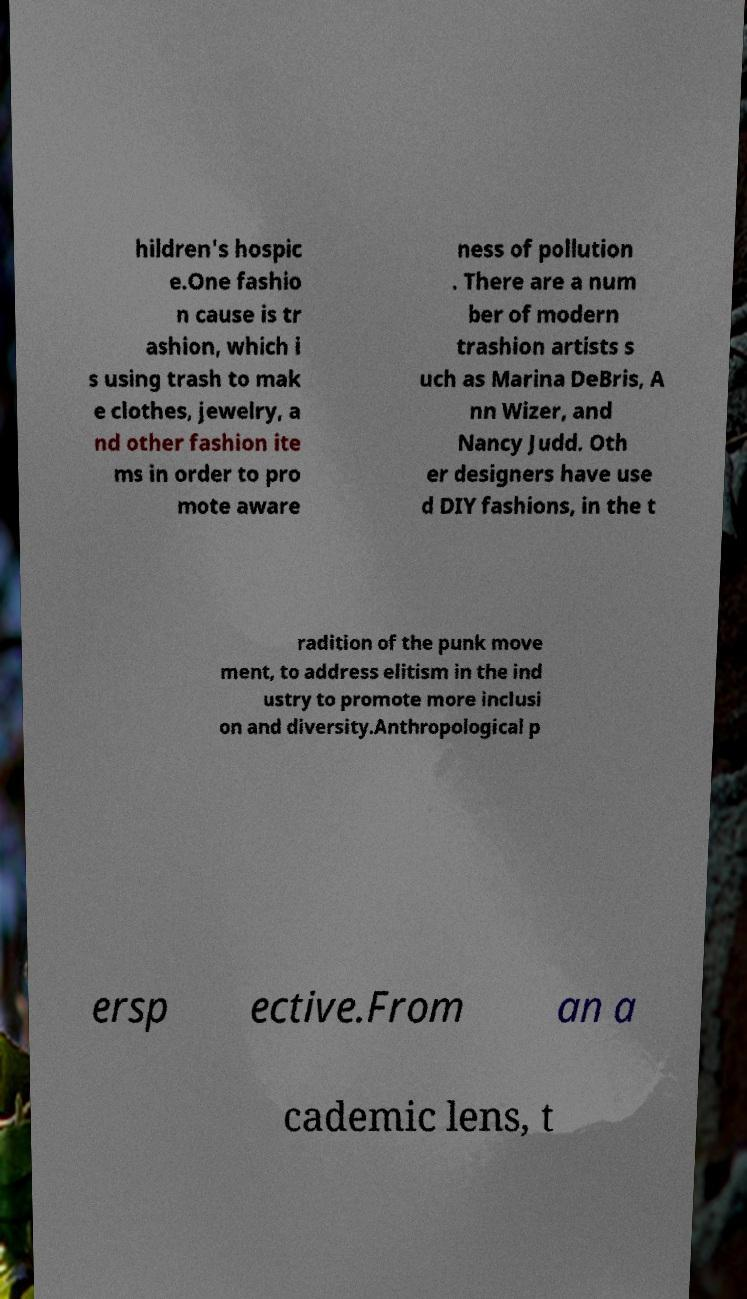Could you assist in decoding the text presented in this image and type it out clearly? hildren's hospic e.One fashio n cause is tr ashion, which i s using trash to mak e clothes, jewelry, a nd other fashion ite ms in order to pro mote aware ness of pollution . There are a num ber of modern trashion artists s uch as Marina DeBris, A nn Wizer, and Nancy Judd. Oth er designers have use d DIY fashions, in the t radition of the punk move ment, to address elitism in the ind ustry to promote more inclusi on and diversity.Anthropological p ersp ective.From an a cademic lens, t 